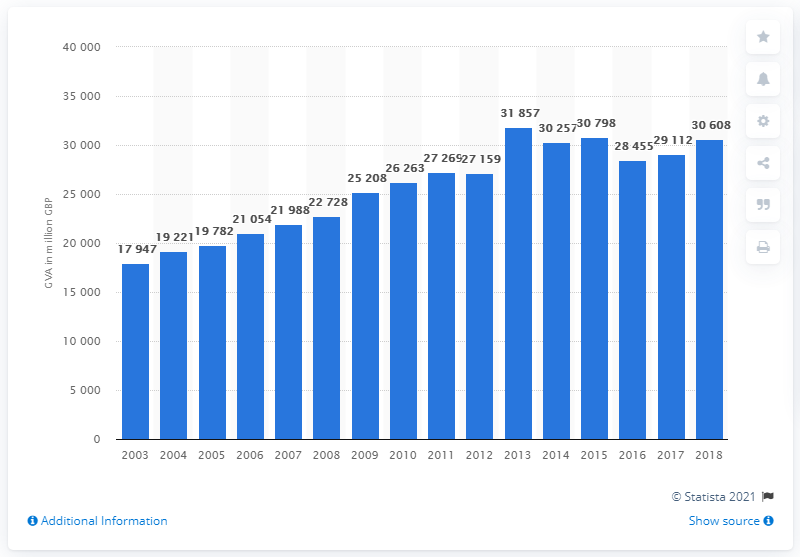List a handful of essential elements in this visual. In 2018, food retailing contributed a significant amount to the UK economy, with a total contribution of 307,980. 